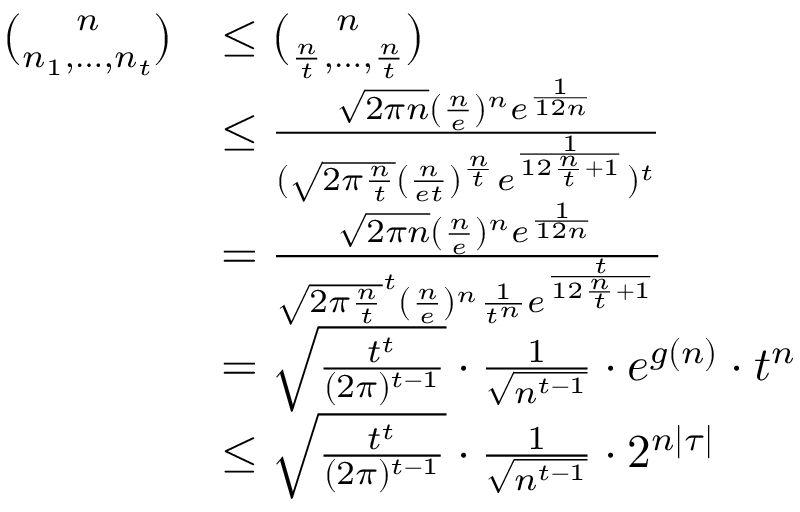<formula> <loc_0><loc_0><loc_500><loc_500>\begin{array} { r l } { \binom { n } { n _ { 1 } , \dots , n _ { t } } } & { \leq \binom { n } { \frac { n } { t } , \dots , \frac { n } { t } } } \\ & { \leq \frac { \sqrt { 2 \pi n } ( \frac { n } { e } ) ^ { n } e ^ { \frac { 1 } { 1 2 n } } } { ( \sqrt { 2 \pi \frac { n } { t } } ( \frac { n } { e t } ) ^ { \frac { n } { t } } e ^ { \frac { 1 } { 1 2 \frac { n } { t } + 1 } } ) ^ { t } } } \\ & { = \frac { \sqrt { 2 \pi n } ( \frac { n } { e } ) ^ { n } e ^ { \frac { 1 } { 1 2 n } } } { \sqrt { 2 \pi \frac { n } { t } } ^ { t } ( \frac { n } { e } ) ^ { n } \frac { 1 } { t ^ { n } } e ^ { \frac { t } { 1 2 \frac { n } { t } + 1 } } } } \\ & { = \sqrt { \frac { t ^ { t } } { ( 2 \pi ) ^ { t - 1 } } } \cdot \frac { 1 } { \sqrt { n ^ { t - 1 } } } \cdot e ^ { g ( n ) } \cdot t ^ { n } } \\ & { \leq \sqrt { \frac { t ^ { t } } { ( 2 \pi ) ^ { t - 1 } } } \cdot \frac { 1 } { \sqrt { n ^ { t - 1 } } } \cdot 2 ^ { n | \tau | } } \end{array}</formula> 